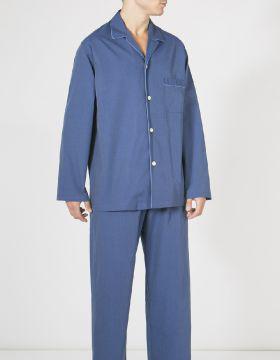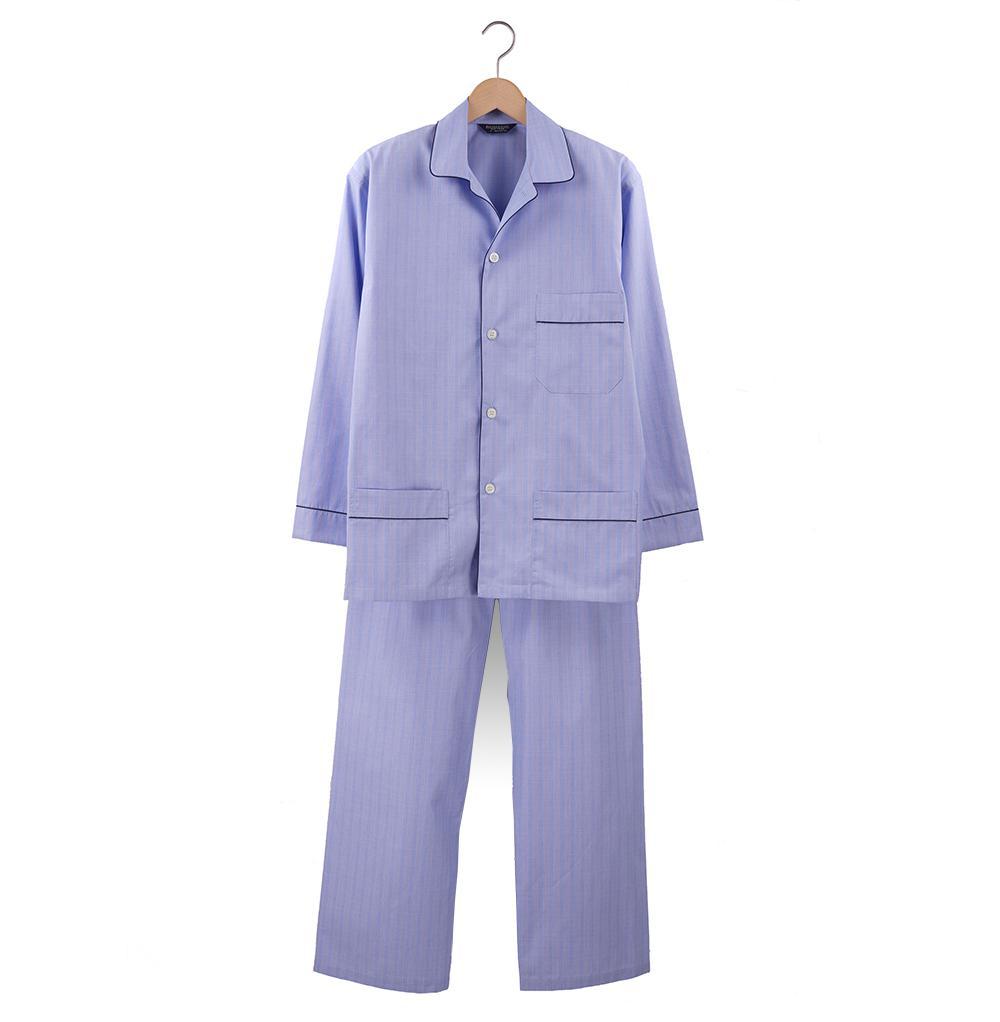The first image is the image on the left, the second image is the image on the right. Assess this claim about the two images: "An image shows two overlapping sleep outfits that are not worn by models or mannequins.". Correct or not? Answer yes or no. No. The first image is the image on the left, the second image is the image on the right. For the images displayed, is the sentence "One pair of men's blue pajamas with long sleeves is worn by a model, while a second pair is displayed on a hanger." factually correct? Answer yes or no. Yes. 